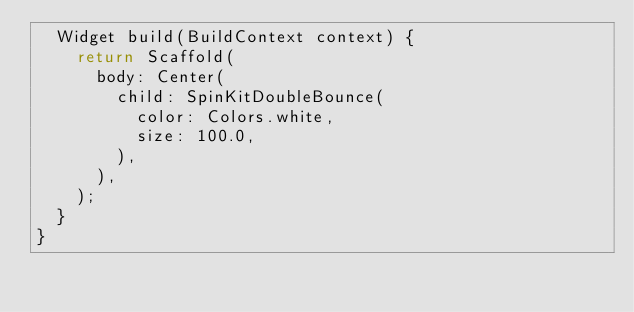<code> <loc_0><loc_0><loc_500><loc_500><_Dart_>  Widget build(BuildContext context) {
    return Scaffold(
      body: Center(
        child: SpinKitDoubleBounce(
          color: Colors.white,
          size: 100.0,
        ),
      ),
    );
  }
}
</code> 